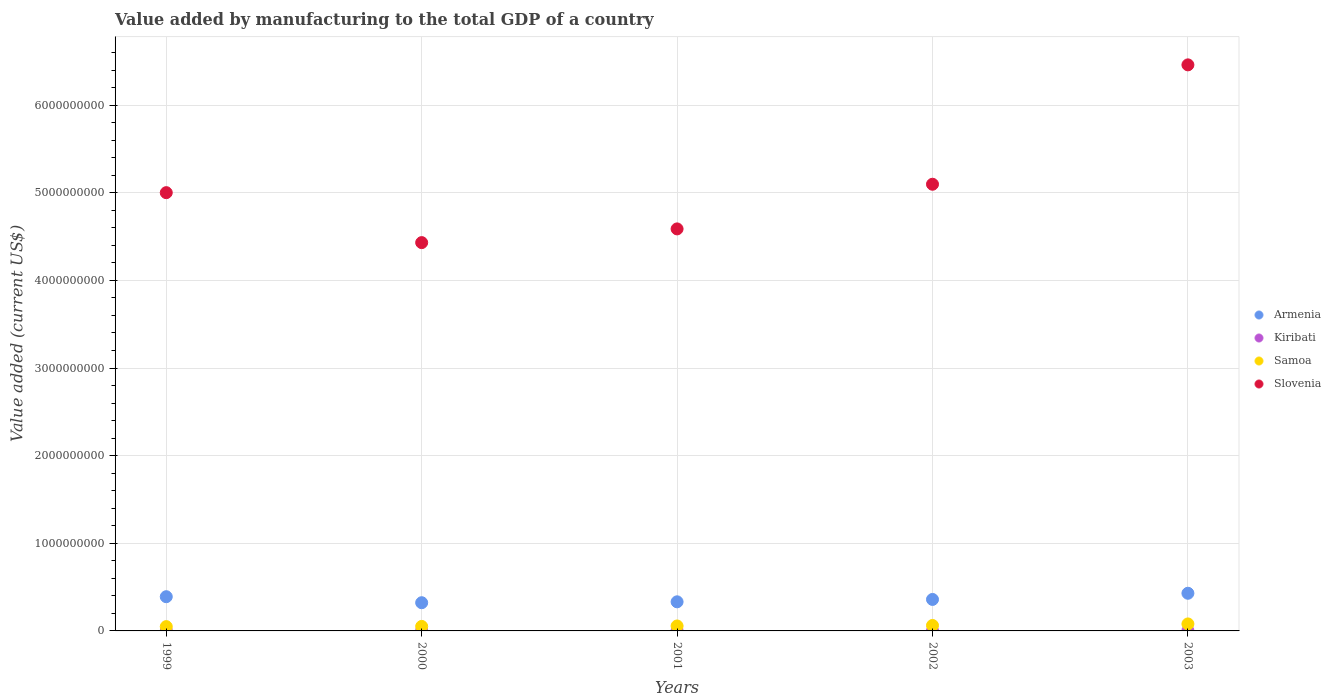How many different coloured dotlines are there?
Offer a terse response. 4. What is the value added by manufacturing to the total GDP in Samoa in 2001?
Your response must be concise. 5.65e+07. Across all years, what is the maximum value added by manufacturing to the total GDP in Samoa?
Make the answer very short. 7.98e+07. Across all years, what is the minimum value added by manufacturing to the total GDP in Samoa?
Offer a very short reply. 4.91e+07. In which year was the value added by manufacturing to the total GDP in Kiribati maximum?
Offer a terse response. 2003. In which year was the value added by manufacturing to the total GDP in Samoa minimum?
Your answer should be very brief. 1999. What is the total value added by manufacturing to the total GDP in Samoa in the graph?
Your answer should be very brief. 2.99e+08. What is the difference between the value added by manufacturing to the total GDP in Armenia in 2002 and that in 2003?
Offer a terse response. -7.05e+07. What is the difference between the value added by manufacturing to the total GDP in Armenia in 2002 and the value added by manufacturing to the total GDP in Kiribati in 2003?
Ensure brevity in your answer.  3.56e+08. What is the average value added by manufacturing to the total GDP in Slovenia per year?
Provide a short and direct response. 5.12e+09. In the year 2003, what is the difference between the value added by manufacturing to the total GDP in Kiribati and value added by manufacturing to the total GDP in Slovenia?
Keep it short and to the point. -6.46e+09. In how many years, is the value added by manufacturing to the total GDP in Armenia greater than 2200000000 US$?
Make the answer very short. 0. What is the ratio of the value added by manufacturing to the total GDP in Slovenia in 2002 to that in 2003?
Make the answer very short. 0.79. Is the value added by manufacturing to the total GDP in Kiribati in 2000 less than that in 2001?
Offer a terse response. No. Is the difference between the value added by manufacturing to the total GDP in Kiribati in 1999 and 2001 greater than the difference between the value added by manufacturing to the total GDP in Slovenia in 1999 and 2001?
Your answer should be compact. No. What is the difference between the highest and the second highest value added by manufacturing to the total GDP in Kiribati?
Provide a short and direct response. 1.44e+05. What is the difference between the highest and the lowest value added by manufacturing to the total GDP in Kiribati?
Provide a short and direct response. 8.81e+05. Is it the case that in every year, the sum of the value added by manufacturing to the total GDP in Kiribati and value added by manufacturing to the total GDP in Samoa  is greater than the sum of value added by manufacturing to the total GDP in Armenia and value added by manufacturing to the total GDP in Slovenia?
Your answer should be very brief. No. Is it the case that in every year, the sum of the value added by manufacturing to the total GDP in Samoa and value added by manufacturing to the total GDP in Kiribati  is greater than the value added by manufacturing to the total GDP in Slovenia?
Keep it short and to the point. No. Does the value added by manufacturing to the total GDP in Samoa monotonically increase over the years?
Provide a succinct answer. Yes. Does the graph contain any zero values?
Give a very brief answer. No. How many legend labels are there?
Give a very brief answer. 4. How are the legend labels stacked?
Ensure brevity in your answer.  Vertical. What is the title of the graph?
Offer a terse response. Value added by manufacturing to the total GDP of a country. What is the label or title of the X-axis?
Offer a very short reply. Years. What is the label or title of the Y-axis?
Offer a very short reply. Value added (current US$). What is the Value added (current US$) of Armenia in 1999?
Make the answer very short. 3.90e+08. What is the Value added (current US$) in Kiribati in 1999?
Provide a succinct answer. 3.52e+06. What is the Value added (current US$) in Samoa in 1999?
Your answer should be very brief. 4.91e+07. What is the Value added (current US$) of Slovenia in 1999?
Make the answer very short. 5.00e+09. What is the Value added (current US$) of Armenia in 2000?
Provide a short and direct response. 3.22e+08. What is the Value added (current US$) of Kiribati in 2000?
Provide a succinct answer. 2.98e+06. What is the Value added (current US$) of Samoa in 2000?
Offer a very short reply. 5.13e+07. What is the Value added (current US$) of Slovenia in 2000?
Keep it short and to the point. 4.43e+09. What is the Value added (current US$) of Armenia in 2001?
Your answer should be compact. 3.32e+08. What is the Value added (current US$) of Kiribati in 2001?
Provide a short and direct response. 2.78e+06. What is the Value added (current US$) in Samoa in 2001?
Provide a succinct answer. 5.65e+07. What is the Value added (current US$) in Slovenia in 2001?
Your answer should be very brief. 4.59e+09. What is the Value added (current US$) of Armenia in 2002?
Give a very brief answer. 3.59e+08. What is the Value added (current US$) in Kiribati in 2002?
Ensure brevity in your answer.  2.85e+06. What is the Value added (current US$) of Samoa in 2002?
Your answer should be compact. 6.21e+07. What is the Value added (current US$) in Slovenia in 2002?
Provide a succinct answer. 5.10e+09. What is the Value added (current US$) in Armenia in 2003?
Make the answer very short. 4.30e+08. What is the Value added (current US$) in Kiribati in 2003?
Provide a succinct answer. 3.66e+06. What is the Value added (current US$) of Samoa in 2003?
Provide a succinct answer. 7.98e+07. What is the Value added (current US$) in Slovenia in 2003?
Give a very brief answer. 6.46e+09. Across all years, what is the maximum Value added (current US$) of Armenia?
Keep it short and to the point. 4.30e+08. Across all years, what is the maximum Value added (current US$) of Kiribati?
Your answer should be very brief. 3.66e+06. Across all years, what is the maximum Value added (current US$) of Samoa?
Provide a short and direct response. 7.98e+07. Across all years, what is the maximum Value added (current US$) in Slovenia?
Make the answer very short. 6.46e+09. Across all years, what is the minimum Value added (current US$) of Armenia?
Keep it short and to the point. 3.22e+08. Across all years, what is the minimum Value added (current US$) of Kiribati?
Offer a very short reply. 2.78e+06. Across all years, what is the minimum Value added (current US$) in Samoa?
Keep it short and to the point. 4.91e+07. Across all years, what is the minimum Value added (current US$) in Slovenia?
Give a very brief answer. 4.43e+09. What is the total Value added (current US$) in Armenia in the graph?
Give a very brief answer. 1.83e+09. What is the total Value added (current US$) in Kiribati in the graph?
Give a very brief answer. 1.58e+07. What is the total Value added (current US$) in Samoa in the graph?
Make the answer very short. 2.99e+08. What is the total Value added (current US$) of Slovenia in the graph?
Your response must be concise. 2.56e+1. What is the difference between the Value added (current US$) in Armenia in 1999 and that in 2000?
Your answer should be compact. 6.86e+07. What is the difference between the Value added (current US$) of Kiribati in 1999 and that in 2000?
Give a very brief answer. 5.42e+05. What is the difference between the Value added (current US$) of Samoa in 1999 and that in 2000?
Make the answer very short. -2.28e+06. What is the difference between the Value added (current US$) in Slovenia in 1999 and that in 2000?
Provide a succinct answer. 5.70e+08. What is the difference between the Value added (current US$) of Armenia in 1999 and that in 2001?
Provide a succinct answer. 5.83e+07. What is the difference between the Value added (current US$) of Kiribati in 1999 and that in 2001?
Offer a very short reply. 7.37e+05. What is the difference between the Value added (current US$) of Samoa in 1999 and that in 2001?
Your response must be concise. -7.41e+06. What is the difference between the Value added (current US$) in Slovenia in 1999 and that in 2001?
Keep it short and to the point. 4.14e+08. What is the difference between the Value added (current US$) in Armenia in 1999 and that in 2002?
Your answer should be very brief. 3.12e+07. What is the difference between the Value added (current US$) in Kiribati in 1999 and that in 2002?
Your answer should be compact. 6.74e+05. What is the difference between the Value added (current US$) in Samoa in 1999 and that in 2002?
Keep it short and to the point. -1.30e+07. What is the difference between the Value added (current US$) in Slovenia in 1999 and that in 2002?
Offer a very short reply. -9.61e+07. What is the difference between the Value added (current US$) of Armenia in 1999 and that in 2003?
Ensure brevity in your answer.  -3.93e+07. What is the difference between the Value added (current US$) of Kiribati in 1999 and that in 2003?
Your answer should be very brief. -1.44e+05. What is the difference between the Value added (current US$) in Samoa in 1999 and that in 2003?
Make the answer very short. -3.07e+07. What is the difference between the Value added (current US$) in Slovenia in 1999 and that in 2003?
Ensure brevity in your answer.  -1.46e+09. What is the difference between the Value added (current US$) of Armenia in 2000 and that in 2001?
Keep it short and to the point. -1.03e+07. What is the difference between the Value added (current US$) in Kiribati in 2000 and that in 2001?
Your response must be concise. 1.95e+05. What is the difference between the Value added (current US$) of Samoa in 2000 and that in 2001?
Your answer should be very brief. -5.14e+06. What is the difference between the Value added (current US$) of Slovenia in 2000 and that in 2001?
Make the answer very short. -1.56e+08. What is the difference between the Value added (current US$) of Armenia in 2000 and that in 2002?
Keep it short and to the point. -3.74e+07. What is the difference between the Value added (current US$) of Kiribati in 2000 and that in 2002?
Offer a terse response. 1.32e+05. What is the difference between the Value added (current US$) of Samoa in 2000 and that in 2002?
Your answer should be compact. -1.08e+07. What is the difference between the Value added (current US$) of Slovenia in 2000 and that in 2002?
Provide a succinct answer. -6.66e+08. What is the difference between the Value added (current US$) of Armenia in 2000 and that in 2003?
Provide a short and direct response. -1.08e+08. What is the difference between the Value added (current US$) of Kiribati in 2000 and that in 2003?
Provide a short and direct response. -6.86e+05. What is the difference between the Value added (current US$) of Samoa in 2000 and that in 2003?
Ensure brevity in your answer.  -2.84e+07. What is the difference between the Value added (current US$) in Slovenia in 2000 and that in 2003?
Ensure brevity in your answer.  -2.03e+09. What is the difference between the Value added (current US$) of Armenia in 2001 and that in 2002?
Give a very brief answer. -2.71e+07. What is the difference between the Value added (current US$) of Kiribati in 2001 and that in 2002?
Make the answer very short. -6.24e+04. What is the difference between the Value added (current US$) in Samoa in 2001 and that in 2002?
Keep it short and to the point. -5.63e+06. What is the difference between the Value added (current US$) in Slovenia in 2001 and that in 2002?
Keep it short and to the point. -5.10e+08. What is the difference between the Value added (current US$) of Armenia in 2001 and that in 2003?
Provide a succinct answer. -9.76e+07. What is the difference between the Value added (current US$) in Kiribati in 2001 and that in 2003?
Make the answer very short. -8.81e+05. What is the difference between the Value added (current US$) of Samoa in 2001 and that in 2003?
Offer a very short reply. -2.33e+07. What is the difference between the Value added (current US$) of Slovenia in 2001 and that in 2003?
Your answer should be compact. -1.87e+09. What is the difference between the Value added (current US$) in Armenia in 2002 and that in 2003?
Make the answer very short. -7.05e+07. What is the difference between the Value added (current US$) in Kiribati in 2002 and that in 2003?
Provide a succinct answer. -8.19e+05. What is the difference between the Value added (current US$) of Samoa in 2002 and that in 2003?
Your answer should be very brief. -1.76e+07. What is the difference between the Value added (current US$) of Slovenia in 2002 and that in 2003?
Keep it short and to the point. -1.36e+09. What is the difference between the Value added (current US$) of Armenia in 1999 and the Value added (current US$) of Kiribati in 2000?
Your answer should be very brief. 3.87e+08. What is the difference between the Value added (current US$) of Armenia in 1999 and the Value added (current US$) of Samoa in 2000?
Provide a succinct answer. 3.39e+08. What is the difference between the Value added (current US$) in Armenia in 1999 and the Value added (current US$) in Slovenia in 2000?
Provide a short and direct response. -4.04e+09. What is the difference between the Value added (current US$) of Kiribati in 1999 and the Value added (current US$) of Samoa in 2000?
Your answer should be very brief. -4.78e+07. What is the difference between the Value added (current US$) of Kiribati in 1999 and the Value added (current US$) of Slovenia in 2000?
Keep it short and to the point. -4.43e+09. What is the difference between the Value added (current US$) in Samoa in 1999 and the Value added (current US$) in Slovenia in 2000?
Provide a succinct answer. -4.38e+09. What is the difference between the Value added (current US$) of Armenia in 1999 and the Value added (current US$) of Kiribati in 2001?
Offer a very short reply. 3.88e+08. What is the difference between the Value added (current US$) in Armenia in 1999 and the Value added (current US$) in Samoa in 2001?
Offer a very short reply. 3.34e+08. What is the difference between the Value added (current US$) of Armenia in 1999 and the Value added (current US$) of Slovenia in 2001?
Offer a terse response. -4.20e+09. What is the difference between the Value added (current US$) of Kiribati in 1999 and the Value added (current US$) of Samoa in 2001?
Your answer should be very brief. -5.30e+07. What is the difference between the Value added (current US$) of Kiribati in 1999 and the Value added (current US$) of Slovenia in 2001?
Give a very brief answer. -4.58e+09. What is the difference between the Value added (current US$) of Samoa in 1999 and the Value added (current US$) of Slovenia in 2001?
Offer a very short reply. -4.54e+09. What is the difference between the Value added (current US$) in Armenia in 1999 and the Value added (current US$) in Kiribati in 2002?
Your response must be concise. 3.88e+08. What is the difference between the Value added (current US$) of Armenia in 1999 and the Value added (current US$) of Samoa in 2002?
Make the answer very short. 3.28e+08. What is the difference between the Value added (current US$) of Armenia in 1999 and the Value added (current US$) of Slovenia in 2002?
Offer a very short reply. -4.71e+09. What is the difference between the Value added (current US$) of Kiribati in 1999 and the Value added (current US$) of Samoa in 2002?
Keep it short and to the point. -5.86e+07. What is the difference between the Value added (current US$) in Kiribati in 1999 and the Value added (current US$) in Slovenia in 2002?
Your answer should be compact. -5.09e+09. What is the difference between the Value added (current US$) in Samoa in 1999 and the Value added (current US$) in Slovenia in 2002?
Provide a short and direct response. -5.05e+09. What is the difference between the Value added (current US$) of Armenia in 1999 and the Value added (current US$) of Kiribati in 2003?
Ensure brevity in your answer.  3.87e+08. What is the difference between the Value added (current US$) of Armenia in 1999 and the Value added (current US$) of Samoa in 2003?
Keep it short and to the point. 3.11e+08. What is the difference between the Value added (current US$) of Armenia in 1999 and the Value added (current US$) of Slovenia in 2003?
Your response must be concise. -6.07e+09. What is the difference between the Value added (current US$) in Kiribati in 1999 and the Value added (current US$) in Samoa in 2003?
Ensure brevity in your answer.  -7.62e+07. What is the difference between the Value added (current US$) in Kiribati in 1999 and the Value added (current US$) in Slovenia in 2003?
Provide a succinct answer. -6.46e+09. What is the difference between the Value added (current US$) in Samoa in 1999 and the Value added (current US$) in Slovenia in 2003?
Your answer should be very brief. -6.41e+09. What is the difference between the Value added (current US$) of Armenia in 2000 and the Value added (current US$) of Kiribati in 2001?
Your response must be concise. 3.19e+08. What is the difference between the Value added (current US$) in Armenia in 2000 and the Value added (current US$) in Samoa in 2001?
Ensure brevity in your answer.  2.65e+08. What is the difference between the Value added (current US$) of Armenia in 2000 and the Value added (current US$) of Slovenia in 2001?
Your response must be concise. -4.27e+09. What is the difference between the Value added (current US$) in Kiribati in 2000 and the Value added (current US$) in Samoa in 2001?
Give a very brief answer. -5.35e+07. What is the difference between the Value added (current US$) of Kiribati in 2000 and the Value added (current US$) of Slovenia in 2001?
Your answer should be very brief. -4.58e+09. What is the difference between the Value added (current US$) in Samoa in 2000 and the Value added (current US$) in Slovenia in 2001?
Your answer should be compact. -4.54e+09. What is the difference between the Value added (current US$) in Armenia in 2000 and the Value added (current US$) in Kiribati in 2002?
Your response must be concise. 3.19e+08. What is the difference between the Value added (current US$) of Armenia in 2000 and the Value added (current US$) of Samoa in 2002?
Provide a short and direct response. 2.60e+08. What is the difference between the Value added (current US$) in Armenia in 2000 and the Value added (current US$) in Slovenia in 2002?
Your answer should be very brief. -4.78e+09. What is the difference between the Value added (current US$) in Kiribati in 2000 and the Value added (current US$) in Samoa in 2002?
Your response must be concise. -5.91e+07. What is the difference between the Value added (current US$) in Kiribati in 2000 and the Value added (current US$) in Slovenia in 2002?
Your response must be concise. -5.09e+09. What is the difference between the Value added (current US$) of Samoa in 2000 and the Value added (current US$) of Slovenia in 2002?
Give a very brief answer. -5.05e+09. What is the difference between the Value added (current US$) in Armenia in 2000 and the Value added (current US$) in Kiribati in 2003?
Give a very brief answer. 3.18e+08. What is the difference between the Value added (current US$) of Armenia in 2000 and the Value added (current US$) of Samoa in 2003?
Keep it short and to the point. 2.42e+08. What is the difference between the Value added (current US$) of Armenia in 2000 and the Value added (current US$) of Slovenia in 2003?
Offer a very short reply. -6.14e+09. What is the difference between the Value added (current US$) of Kiribati in 2000 and the Value added (current US$) of Samoa in 2003?
Your answer should be very brief. -7.68e+07. What is the difference between the Value added (current US$) of Kiribati in 2000 and the Value added (current US$) of Slovenia in 2003?
Your answer should be very brief. -6.46e+09. What is the difference between the Value added (current US$) in Samoa in 2000 and the Value added (current US$) in Slovenia in 2003?
Make the answer very short. -6.41e+09. What is the difference between the Value added (current US$) in Armenia in 2001 and the Value added (current US$) in Kiribati in 2002?
Your response must be concise. 3.29e+08. What is the difference between the Value added (current US$) of Armenia in 2001 and the Value added (current US$) of Samoa in 2002?
Your answer should be compact. 2.70e+08. What is the difference between the Value added (current US$) of Armenia in 2001 and the Value added (current US$) of Slovenia in 2002?
Your answer should be very brief. -4.77e+09. What is the difference between the Value added (current US$) in Kiribati in 2001 and the Value added (current US$) in Samoa in 2002?
Provide a short and direct response. -5.93e+07. What is the difference between the Value added (current US$) in Kiribati in 2001 and the Value added (current US$) in Slovenia in 2002?
Provide a short and direct response. -5.09e+09. What is the difference between the Value added (current US$) in Samoa in 2001 and the Value added (current US$) in Slovenia in 2002?
Offer a very short reply. -5.04e+09. What is the difference between the Value added (current US$) in Armenia in 2001 and the Value added (current US$) in Kiribati in 2003?
Make the answer very short. 3.28e+08. What is the difference between the Value added (current US$) of Armenia in 2001 and the Value added (current US$) of Samoa in 2003?
Your response must be concise. 2.52e+08. What is the difference between the Value added (current US$) of Armenia in 2001 and the Value added (current US$) of Slovenia in 2003?
Offer a very short reply. -6.13e+09. What is the difference between the Value added (current US$) of Kiribati in 2001 and the Value added (current US$) of Samoa in 2003?
Your response must be concise. -7.70e+07. What is the difference between the Value added (current US$) of Kiribati in 2001 and the Value added (current US$) of Slovenia in 2003?
Your answer should be compact. -6.46e+09. What is the difference between the Value added (current US$) of Samoa in 2001 and the Value added (current US$) of Slovenia in 2003?
Your answer should be very brief. -6.40e+09. What is the difference between the Value added (current US$) of Armenia in 2002 and the Value added (current US$) of Kiribati in 2003?
Provide a short and direct response. 3.56e+08. What is the difference between the Value added (current US$) in Armenia in 2002 and the Value added (current US$) in Samoa in 2003?
Offer a very short reply. 2.80e+08. What is the difference between the Value added (current US$) in Armenia in 2002 and the Value added (current US$) in Slovenia in 2003?
Keep it short and to the point. -6.10e+09. What is the difference between the Value added (current US$) in Kiribati in 2002 and the Value added (current US$) in Samoa in 2003?
Ensure brevity in your answer.  -7.69e+07. What is the difference between the Value added (current US$) of Kiribati in 2002 and the Value added (current US$) of Slovenia in 2003?
Offer a terse response. -6.46e+09. What is the difference between the Value added (current US$) of Samoa in 2002 and the Value added (current US$) of Slovenia in 2003?
Keep it short and to the point. -6.40e+09. What is the average Value added (current US$) of Armenia per year?
Provide a succinct answer. 3.67e+08. What is the average Value added (current US$) of Kiribati per year?
Give a very brief answer. 3.16e+06. What is the average Value added (current US$) in Samoa per year?
Ensure brevity in your answer.  5.98e+07. What is the average Value added (current US$) in Slovenia per year?
Make the answer very short. 5.12e+09. In the year 1999, what is the difference between the Value added (current US$) in Armenia and Value added (current US$) in Kiribati?
Provide a succinct answer. 3.87e+08. In the year 1999, what is the difference between the Value added (current US$) of Armenia and Value added (current US$) of Samoa?
Offer a very short reply. 3.41e+08. In the year 1999, what is the difference between the Value added (current US$) of Armenia and Value added (current US$) of Slovenia?
Your answer should be very brief. -4.61e+09. In the year 1999, what is the difference between the Value added (current US$) of Kiribati and Value added (current US$) of Samoa?
Provide a succinct answer. -4.56e+07. In the year 1999, what is the difference between the Value added (current US$) in Kiribati and Value added (current US$) in Slovenia?
Offer a terse response. -5.00e+09. In the year 1999, what is the difference between the Value added (current US$) of Samoa and Value added (current US$) of Slovenia?
Offer a terse response. -4.95e+09. In the year 2000, what is the difference between the Value added (current US$) of Armenia and Value added (current US$) of Kiribati?
Give a very brief answer. 3.19e+08. In the year 2000, what is the difference between the Value added (current US$) of Armenia and Value added (current US$) of Samoa?
Offer a very short reply. 2.71e+08. In the year 2000, what is the difference between the Value added (current US$) of Armenia and Value added (current US$) of Slovenia?
Provide a short and direct response. -4.11e+09. In the year 2000, what is the difference between the Value added (current US$) in Kiribati and Value added (current US$) in Samoa?
Your response must be concise. -4.84e+07. In the year 2000, what is the difference between the Value added (current US$) of Kiribati and Value added (current US$) of Slovenia?
Offer a very short reply. -4.43e+09. In the year 2000, what is the difference between the Value added (current US$) in Samoa and Value added (current US$) in Slovenia?
Your answer should be compact. -4.38e+09. In the year 2001, what is the difference between the Value added (current US$) in Armenia and Value added (current US$) in Kiribati?
Provide a short and direct response. 3.29e+08. In the year 2001, what is the difference between the Value added (current US$) in Armenia and Value added (current US$) in Samoa?
Provide a succinct answer. 2.76e+08. In the year 2001, what is the difference between the Value added (current US$) of Armenia and Value added (current US$) of Slovenia?
Your response must be concise. -4.26e+09. In the year 2001, what is the difference between the Value added (current US$) in Kiribati and Value added (current US$) in Samoa?
Your answer should be compact. -5.37e+07. In the year 2001, what is the difference between the Value added (current US$) in Kiribati and Value added (current US$) in Slovenia?
Provide a short and direct response. -4.58e+09. In the year 2001, what is the difference between the Value added (current US$) of Samoa and Value added (current US$) of Slovenia?
Provide a short and direct response. -4.53e+09. In the year 2002, what is the difference between the Value added (current US$) of Armenia and Value added (current US$) of Kiribati?
Provide a succinct answer. 3.56e+08. In the year 2002, what is the difference between the Value added (current US$) of Armenia and Value added (current US$) of Samoa?
Make the answer very short. 2.97e+08. In the year 2002, what is the difference between the Value added (current US$) in Armenia and Value added (current US$) in Slovenia?
Your answer should be very brief. -4.74e+09. In the year 2002, what is the difference between the Value added (current US$) of Kiribati and Value added (current US$) of Samoa?
Your answer should be very brief. -5.93e+07. In the year 2002, what is the difference between the Value added (current US$) of Kiribati and Value added (current US$) of Slovenia?
Your response must be concise. -5.09e+09. In the year 2002, what is the difference between the Value added (current US$) of Samoa and Value added (current US$) of Slovenia?
Ensure brevity in your answer.  -5.04e+09. In the year 2003, what is the difference between the Value added (current US$) in Armenia and Value added (current US$) in Kiribati?
Offer a very short reply. 4.26e+08. In the year 2003, what is the difference between the Value added (current US$) in Armenia and Value added (current US$) in Samoa?
Your answer should be very brief. 3.50e+08. In the year 2003, what is the difference between the Value added (current US$) of Armenia and Value added (current US$) of Slovenia?
Offer a terse response. -6.03e+09. In the year 2003, what is the difference between the Value added (current US$) in Kiribati and Value added (current US$) in Samoa?
Offer a very short reply. -7.61e+07. In the year 2003, what is the difference between the Value added (current US$) of Kiribati and Value added (current US$) of Slovenia?
Give a very brief answer. -6.46e+09. In the year 2003, what is the difference between the Value added (current US$) of Samoa and Value added (current US$) of Slovenia?
Your answer should be compact. -6.38e+09. What is the ratio of the Value added (current US$) of Armenia in 1999 to that in 2000?
Ensure brevity in your answer.  1.21. What is the ratio of the Value added (current US$) in Kiribati in 1999 to that in 2000?
Ensure brevity in your answer.  1.18. What is the ratio of the Value added (current US$) in Samoa in 1999 to that in 2000?
Your answer should be very brief. 0.96. What is the ratio of the Value added (current US$) in Slovenia in 1999 to that in 2000?
Offer a terse response. 1.13. What is the ratio of the Value added (current US$) in Armenia in 1999 to that in 2001?
Offer a very short reply. 1.18. What is the ratio of the Value added (current US$) in Kiribati in 1999 to that in 2001?
Provide a short and direct response. 1.26. What is the ratio of the Value added (current US$) of Samoa in 1999 to that in 2001?
Your answer should be compact. 0.87. What is the ratio of the Value added (current US$) in Slovenia in 1999 to that in 2001?
Provide a short and direct response. 1.09. What is the ratio of the Value added (current US$) in Armenia in 1999 to that in 2002?
Give a very brief answer. 1.09. What is the ratio of the Value added (current US$) in Kiribati in 1999 to that in 2002?
Offer a terse response. 1.24. What is the ratio of the Value added (current US$) of Samoa in 1999 to that in 2002?
Provide a succinct answer. 0.79. What is the ratio of the Value added (current US$) in Slovenia in 1999 to that in 2002?
Your answer should be compact. 0.98. What is the ratio of the Value added (current US$) of Armenia in 1999 to that in 2003?
Your answer should be very brief. 0.91. What is the ratio of the Value added (current US$) in Kiribati in 1999 to that in 2003?
Keep it short and to the point. 0.96. What is the ratio of the Value added (current US$) of Samoa in 1999 to that in 2003?
Provide a succinct answer. 0.62. What is the ratio of the Value added (current US$) of Slovenia in 1999 to that in 2003?
Your answer should be compact. 0.77. What is the ratio of the Value added (current US$) in Armenia in 2000 to that in 2001?
Your answer should be very brief. 0.97. What is the ratio of the Value added (current US$) in Kiribati in 2000 to that in 2001?
Your answer should be very brief. 1.07. What is the ratio of the Value added (current US$) of Samoa in 2000 to that in 2001?
Provide a succinct answer. 0.91. What is the ratio of the Value added (current US$) in Slovenia in 2000 to that in 2001?
Provide a succinct answer. 0.97. What is the ratio of the Value added (current US$) in Armenia in 2000 to that in 2002?
Provide a succinct answer. 0.9. What is the ratio of the Value added (current US$) of Kiribati in 2000 to that in 2002?
Provide a succinct answer. 1.05. What is the ratio of the Value added (current US$) of Samoa in 2000 to that in 2002?
Make the answer very short. 0.83. What is the ratio of the Value added (current US$) of Slovenia in 2000 to that in 2002?
Offer a terse response. 0.87. What is the ratio of the Value added (current US$) of Armenia in 2000 to that in 2003?
Give a very brief answer. 0.75. What is the ratio of the Value added (current US$) of Kiribati in 2000 to that in 2003?
Offer a terse response. 0.81. What is the ratio of the Value added (current US$) of Samoa in 2000 to that in 2003?
Ensure brevity in your answer.  0.64. What is the ratio of the Value added (current US$) in Slovenia in 2000 to that in 2003?
Your response must be concise. 0.69. What is the ratio of the Value added (current US$) of Armenia in 2001 to that in 2002?
Offer a terse response. 0.92. What is the ratio of the Value added (current US$) in Kiribati in 2001 to that in 2002?
Provide a succinct answer. 0.98. What is the ratio of the Value added (current US$) in Samoa in 2001 to that in 2002?
Offer a terse response. 0.91. What is the ratio of the Value added (current US$) of Slovenia in 2001 to that in 2002?
Offer a terse response. 0.9. What is the ratio of the Value added (current US$) in Armenia in 2001 to that in 2003?
Give a very brief answer. 0.77. What is the ratio of the Value added (current US$) in Kiribati in 2001 to that in 2003?
Ensure brevity in your answer.  0.76. What is the ratio of the Value added (current US$) in Samoa in 2001 to that in 2003?
Ensure brevity in your answer.  0.71. What is the ratio of the Value added (current US$) in Slovenia in 2001 to that in 2003?
Offer a very short reply. 0.71. What is the ratio of the Value added (current US$) in Armenia in 2002 to that in 2003?
Ensure brevity in your answer.  0.84. What is the ratio of the Value added (current US$) in Kiribati in 2002 to that in 2003?
Provide a succinct answer. 0.78. What is the ratio of the Value added (current US$) in Samoa in 2002 to that in 2003?
Offer a terse response. 0.78. What is the ratio of the Value added (current US$) in Slovenia in 2002 to that in 2003?
Your answer should be compact. 0.79. What is the difference between the highest and the second highest Value added (current US$) in Armenia?
Give a very brief answer. 3.93e+07. What is the difference between the highest and the second highest Value added (current US$) of Kiribati?
Give a very brief answer. 1.44e+05. What is the difference between the highest and the second highest Value added (current US$) in Samoa?
Your answer should be very brief. 1.76e+07. What is the difference between the highest and the second highest Value added (current US$) in Slovenia?
Your answer should be very brief. 1.36e+09. What is the difference between the highest and the lowest Value added (current US$) of Armenia?
Offer a terse response. 1.08e+08. What is the difference between the highest and the lowest Value added (current US$) of Kiribati?
Provide a short and direct response. 8.81e+05. What is the difference between the highest and the lowest Value added (current US$) in Samoa?
Offer a terse response. 3.07e+07. What is the difference between the highest and the lowest Value added (current US$) of Slovenia?
Your response must be concise. 2.03e+09. 